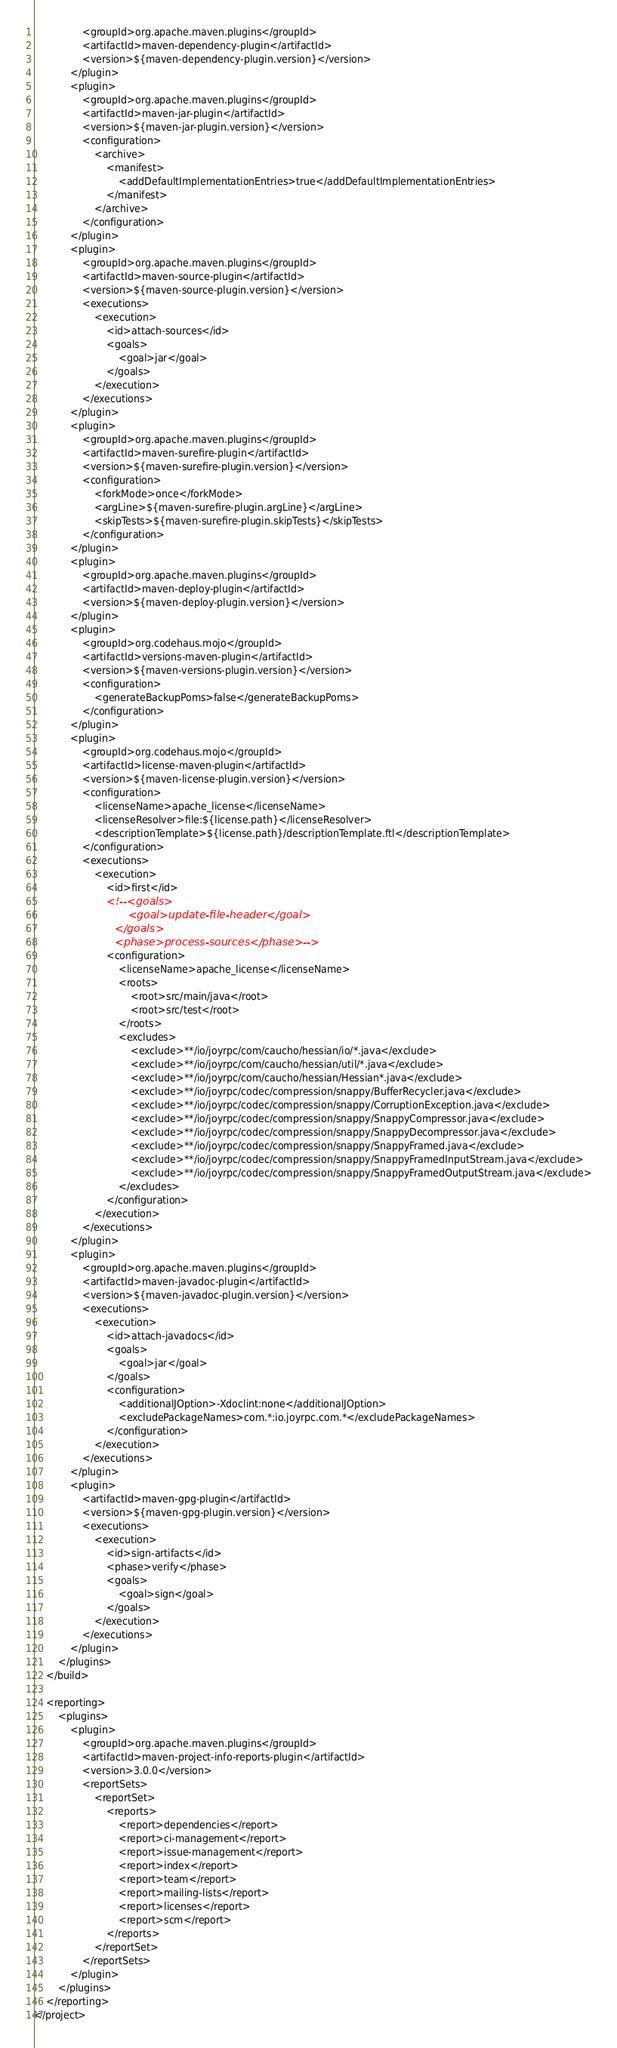Convert code to text. <code><loc_0><loc_0><loc_500><loc_500><_XML_>                <groupId>org.apache.maven.plugins</groupId>
                <artifactId>maven-dependency-plugin</artifactId>
                <version>${maven-dependency-plugin.version}</version>
            </plugin>
            <plugin>
                <groupId>org.apache.maven.plugins</groupId>
                <artifactId>maven-jar-plugin</artifactId>
                <version>${maven-jar-plugin.version}</version>
                <configuration>
                    <archive>
                        <manifest>
                            <addDefaultImplementationEntries>true</addDefaultImplementationEntries>
                        </manifest>
                    </archive>
                </configuration>
            </plugin>
            <plugin>
                <groupId>org.apache.maven.plugins</groupId>
                <artifactId>maven-source-plugin</artifactId>
                <version>${maven-source-plugin.version}</version>
                <executions>
                    <execution>
                        <id>attach-sources</id>
                        <goals>
                            <goal>jar</goal>
                        </goals>
                    </execution>
                </executions>
            </plugin>
            <plugin>
                <groupId>org.apache.maven.plugins</groupId>
                <artifactId>maven-surefire-plugin</artifactId>
                <version>${maven-surefire-plugin.version}</version>
                <configuration>
                    <forkMode>once</forkMode>
                    <argLine>${maven-surefire-plugin.argLine}</argLine>
                    <skipTests>${maven-surefire-plugin.skipTests}</skipTests>
                </configuration>
            </plugin>
            <plugin>
                <groupId>org.apache.maven.plugins</groupId>
                <artifactId>maven-deploy-plugin</artifactId>
                <version>${maven-deploy-plugin.version}</version>
            </plugin>
            <plugin>
                <groupId>org.codehaus.mojo</groupId>
                <artifactId>versions-maven-plugin</artifactId>
                <version>${maven-versions-plugin.version}</version>
                <configuration>
                    <generateBackupPoms>false</generateBackupPoms>
                </configuration>
            </plugin>
            <plugin>
                <groupId>org.codehaus.mojo</groupId>
                <artifactId>license-maven-plugin</artifactId>
                <version>${maven-license-plugin.version}</version>
                <configuration>
                    <licenseName>apache_license</licenseName>
                    <licenseResolver>file:${license.path}</licenseResolver>
                    <descriptionTemplate>${license.path}/descriptionTemplate.ftl</descriptionTemplate>
                </configuration>
                <executions>
                    <execution>
                        <id>first</id>
                        <!--<goals>
                            <goal>update-file-header</goal>
                        </goals>
                        <phase>process-sources</phase>-->
                        <configuration>
                            <licenseName>apache_license</licenseName>
                            <roots>
                                <root>src/main/java</root>
                                <root>src/test</root>
                            </roots>
                            <excludes>
                                <exclude>**/io/joyrpc/com/caucho/hessian/io/*.java</exclude>
                                <exclude>**/io/joyrpc/com/caucho/hessian/util/*.java</exclude>
                                <exclude>**/io/joyrpc/com/caucho/hessian/Hessian*.java</exclude>
                                <exclude>**/io/joyrpc/codec/compression/snappy/BufferRecycler.java</exclude>
                                <exclude>**/io/joyrpc/codec/compression/snappy/CorruptionException.java</exclude>
                                <exclude>**/io/joyrpc/codec/compression/snappy/SnappyCompressor.java</exclude>
                                <exclude>**/io/joyrpc/codec/compression/snappy/SnappyDecompressor.java</exclude>
                                <exclude>**/io/joyrpc/codec/compression/snappy/SnappyFramed.java</exclude>
                                <exclude>**/io/joyrpc/codec/compression/snappy/SnappyFramedInputStream.java</exclude>
                                <exclude>**/io/joyrpc/codec/compression/snappy/SnappyFramedOutputStream.java</exclude>
                            </excludes>
                        </configuration>
                    </execution>
                </executions>
            </plugin>
            <plugin>
                <groupId>org.apache.maven.plugins</groupId>
                <artifactId>maven-javadoc-plugin</artifactId>
                <version>${maven-javadoc-plugin.version}</version>
                <executions>
                    <execution>
                        <id>attach-javadocs</id>
                        <goals>
                            <goal>jar</goal>
                        </goals>
                        <configuration>
                            <additionalJOption>-Xdoclint:none</additionalJOption>
                            <excludePackageNames>com.*:io.joyrpc.com.*</excludePackageNames>
                        </configuration>
                    </execution>
                </executions>
            </plugin>
            <plugin>
                <artifactId>maven-gpg-plugin</artifactId>
                <version>${maven-gpg-plugin.version}</version>
                <executions>
                    <execution>
                        <id>sign-artifacts</id>
                        <phase>verify</phase>
                        <goals>
                            <goal>sign</goal>
                        </goals>
                    </execution>
                </executions>
            </plugin>
        </plugins>
    </build>

    <reporting>
        <plugins>
            <plugin>
                <groupId>org.apache.maven.plugins</groupId>
                <artifactId>maven-project-info-reports-plugin</artifactId>
                <version>3.0.0</version>
                <reportSets>
                    <reportSet>
                        <reports>
                            <report>dependencies</report>
                            <report>ci-management</report>
                            <report>issue-management</report>
                            <report>index</report>
                            <report>team</report>
                            <report>mailing-lists</report>
                            <report>licenses</report>
                            <report>scm</report>
                        </reports>
                    </reportSet>
                </reportSets>
            </plugin>
        </plugins>
    </reporting>
</project></code> 